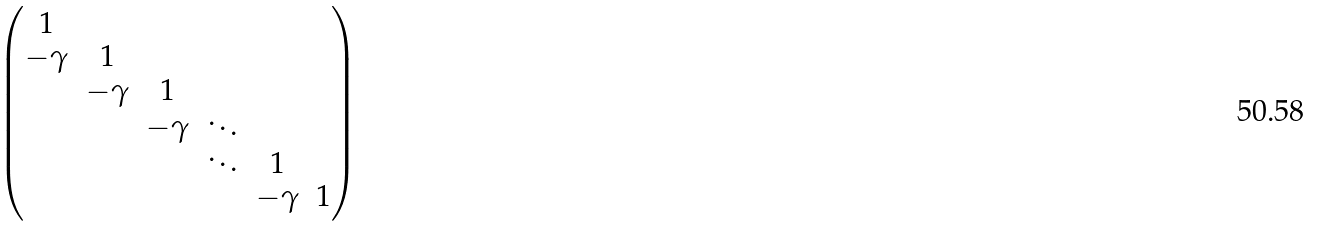<formula> <loc_0><loc_0><loc_500><loc_500>\begin{pmatrix} 1 & & \\ - \gamma & 1 & \\ & - \gamma & 1 & \\ & & - \gamma & \ddots & \\ & & & \ddots & 1 & \\ & & & & - \gamma & 1 \\ \end{pmatrix}</formula> 